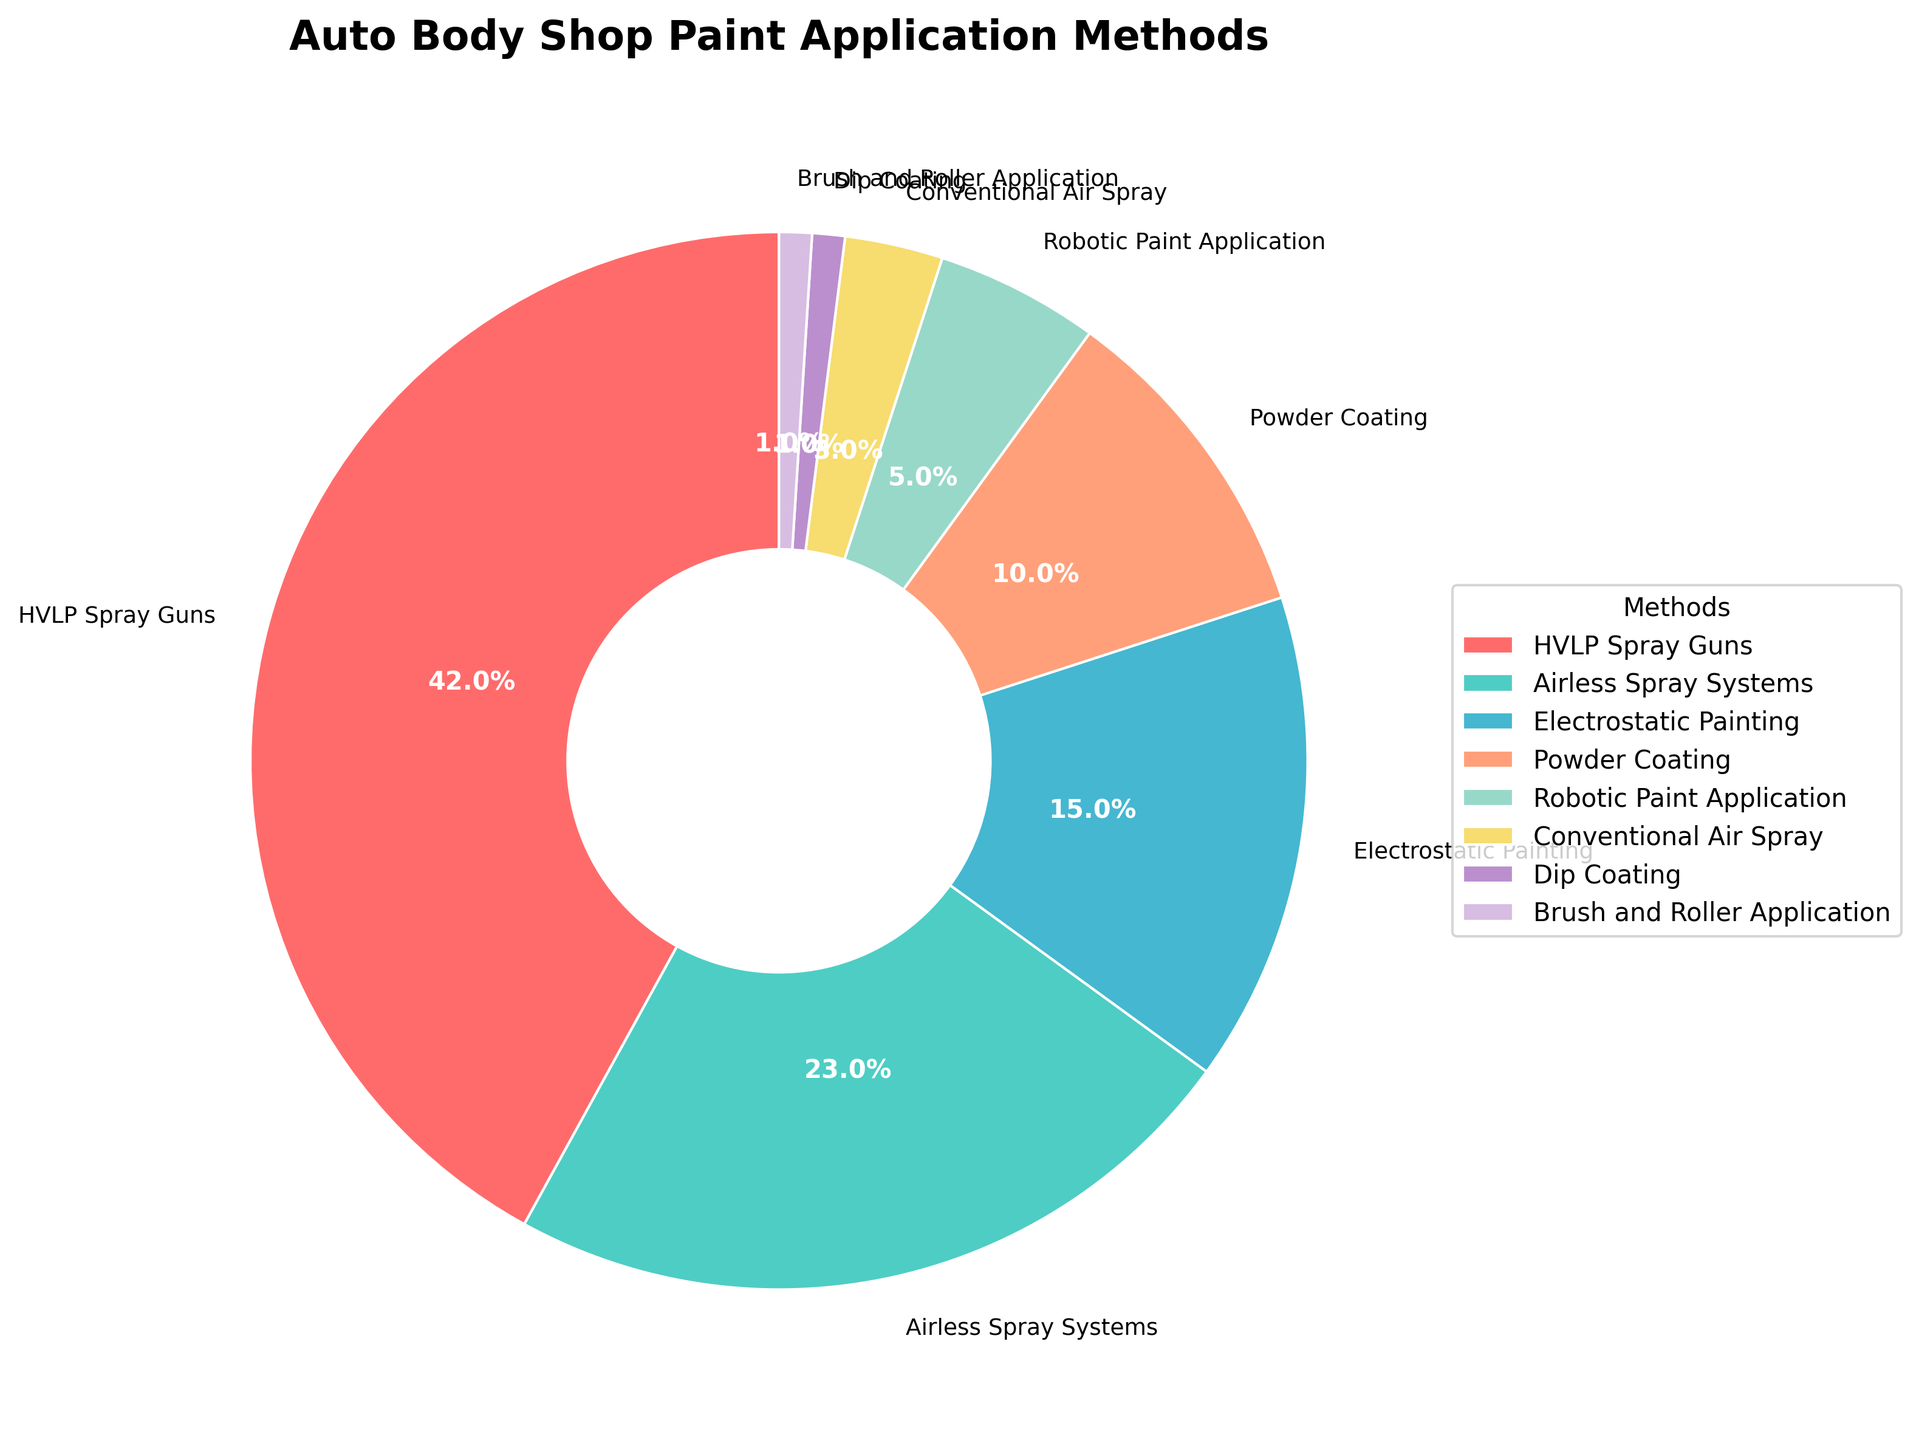What's the most commonly used paint application method among auto body shops? The figure's largest segment represents the most commonly used method. The largest segment is labeled "HVLP Spray Guns" with 42%.
Answer: HVLP Spray Guns Which method has the smallest percentage of use? The figure shows the smallest segment, which is labeled "Brush and Roller Application" with 1%.
Answer: Brush and Roller Application How much more popular is HVLP Spray Guns compared to Powder Coating? HVLP Spray Guns have 42%, and Powder Coating has 10%. The difference is calculated as 42% - 10% = 32%.
Answer: 32% What is the total percentage of shops using Electrostatic Painting and Powder Coating combined? Electrostatic Painting has 15% and Powder Coating has 10%. Adding these together gives 15% + 10% = 25%.
Answer: 25% Are there more shops using Airless Spray Systems than Robotic Paint Application? Airless Spray Systems have 23%, while Robotic Paint Application has 5%. Since 23% > 5%, more shops use Airless Spray Systems.
Answer: Yes Which method is represented by the blue segment in the pie chart? The blue segment is labeled "Airless Spray Systems", which is 23% of the chart.
Answer: Airless Spray Systems What is the combined percentage of the two least used methods? The two least used methods are "Brush and Roller Application" and "Dip Coating", each with 1%. So the combined percentage is 1% + 1% = 2%.
Answer: 2% Compare the popularity of Electrostatic Painting to Conventional Air Spray. Electrostatic Painting has 15% while Conventional Air Spray has 3%. Since 15% > 3%, Electrostatic Painting is more popular.
Answer: Electrostatic Painting How many methods have a usage percentage of 10% or higher? From the pie chart, the methods with 10% or higher usage are HVLP Spray Guns (42%), Airless Spray Systems (23%), Electrostatic Painting (15%), and Powder Coating (10%). There are 4 such methods.
Answer: 4 What is the total percentage of auto body shops using methods other than HVLP Spray Guns? The percentage of HVLP Spray Guns is 42%. The total must be 100%, so other methods' total is 100% - 42% = 58%.
Answer: 58% 